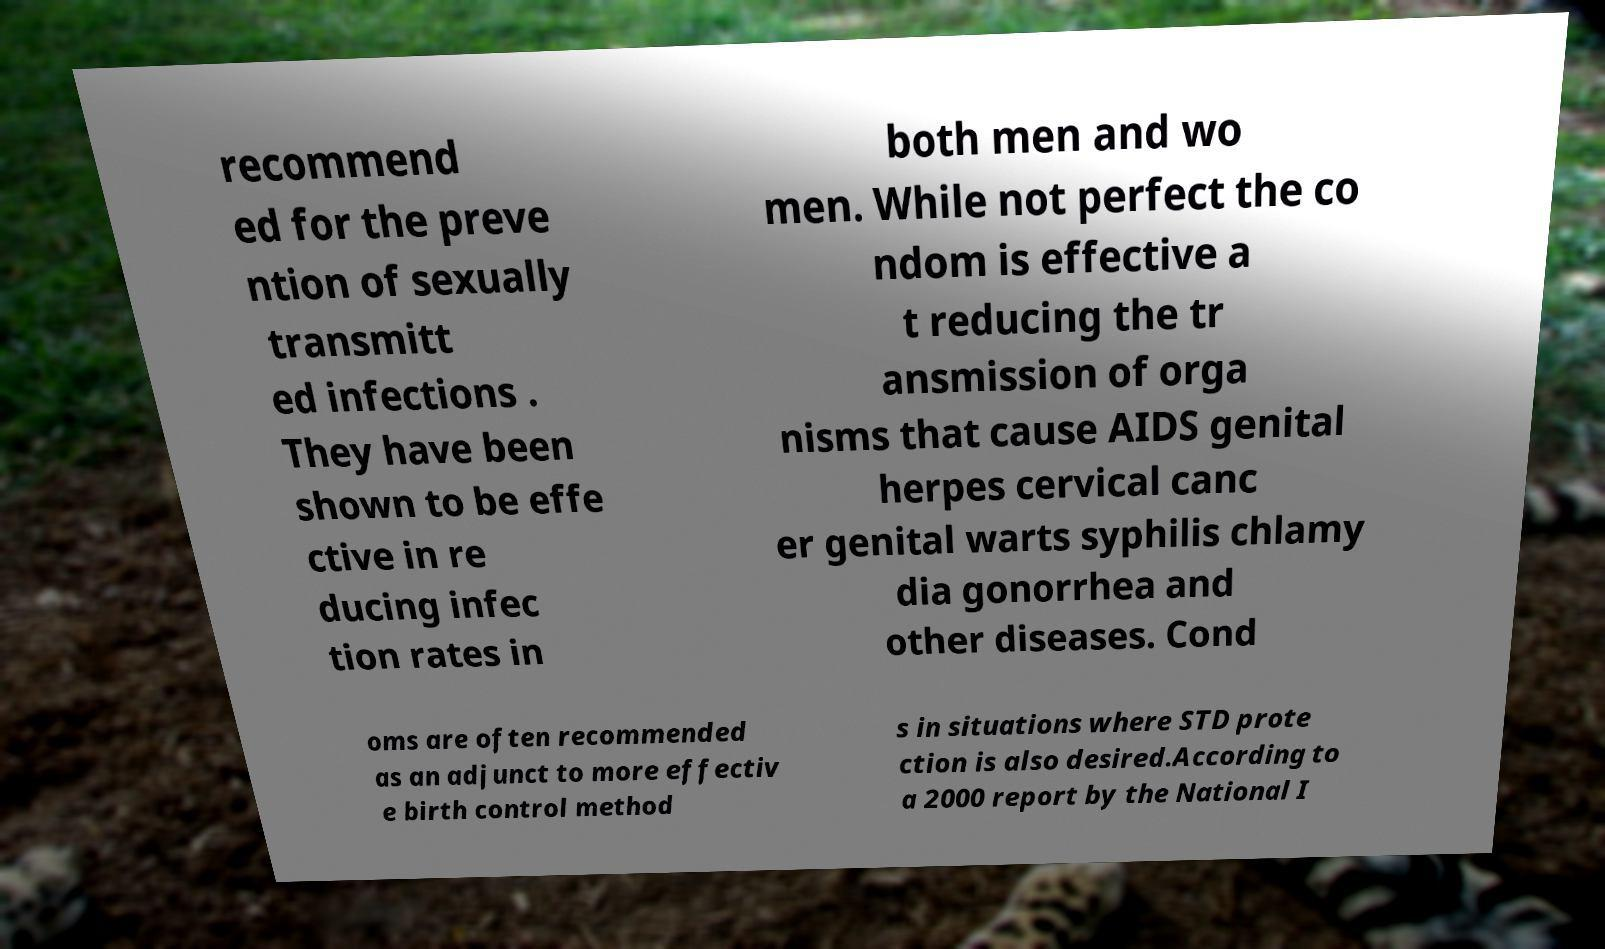What messages or text are displayed in this image? I need them in a readable, typed format. recommend ed for the preve ntion of sexually transmitt ed infections . They have been shown to be effe ctive in re ducing infec tion rates in both men and wo men. While not perfect the co ndom is effective a t reducing the tr ansmission of orga nisms that cause AIDS genital herpes cervical canc er genital warts syphilis chlamy dia gonorrhea and other diseases. Cond oms are often recommended as an adjunct to more effectiv e birth control method s in situations where STD prote ction is also desired.According to a 2000 report by the National I 